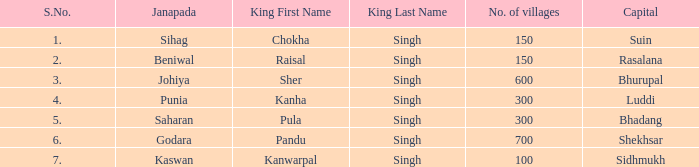What is the average number of villages with a name of janapada of Punia? 300.0. 